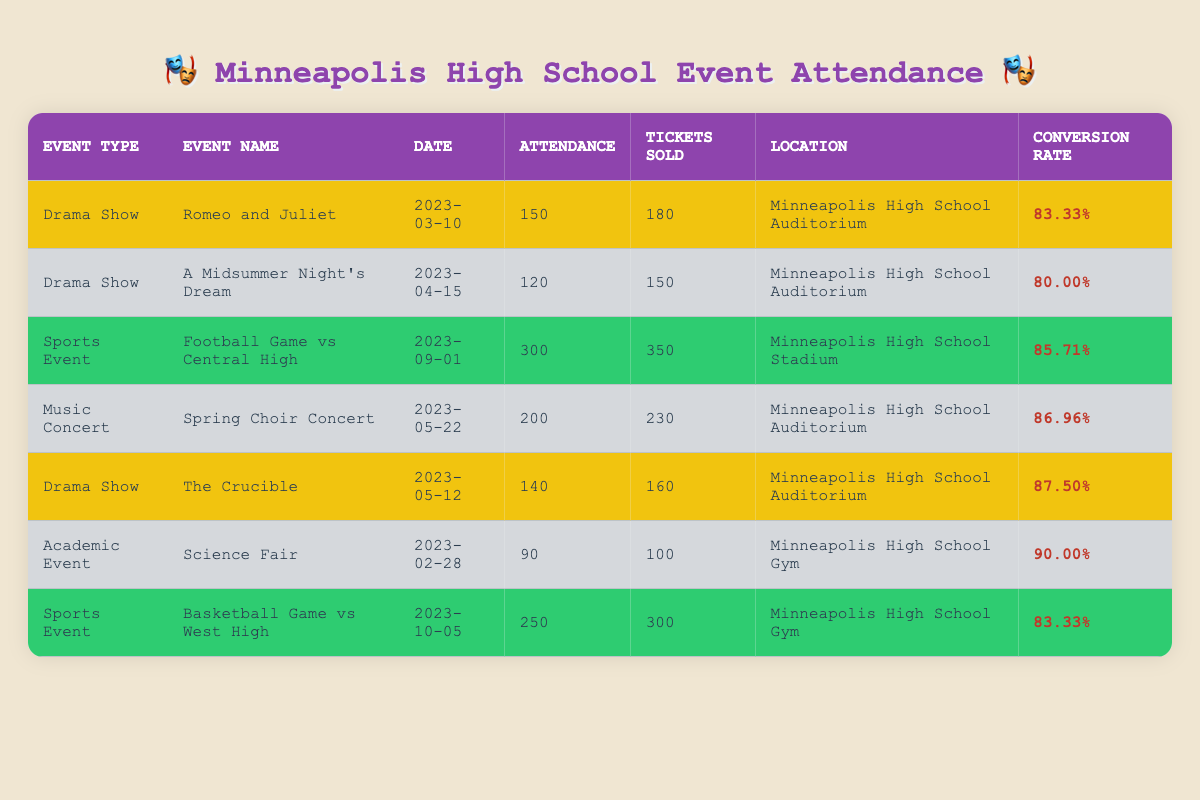What was the attendance of the "A Midsummer Night's Dream" drama show? The event name for "A Midsummer Night's Dream" is listed in the table under the Drama Show category, with the attendance recorded as 120.
Answer: 120 What is the conversion rate for the Spring Choir Concert? The Spring Choir Concert is listed in the table, and its conversion rate is shown as 86.96%.
Answer: 86.96% How many total tickets were sold for all drama shows combined? The drama shows listed are "Romeo and Juliet" (180), "A Midsummer Night's Dream" (150), and "The Crucible" (160). Adding these values gives 180 + 150 + 160 = 490 total tickets sold.
Answer: 490 Is the attendance for the "Science Fair" higher than that of "The Crucible"? The attendance for the Science Fair is 90, while The Crucible has an attendance of 140. Comparing these two values, 90 is less than 140, making the statement false.
Answer: No What is the average attendance for all drama shows? The attendance numbers for the drama shows are 150 (Romeo and Juliet), 120 (A Midsummer Night's Dream), and 140 (The Crucible). To find the average, we total these values: 150 + 120 + 140 = 410, and then divide by 3, resulting in an average of 410/3 = 136.67.
Answer: 136.67 What event had the highest attendance? Looking at the attendance values in the table, the event with the highest attendance is the Football Game vs Central High, with 300 attendees.
Answer: 300 What is the total attendance across all events? Summing the attendance for all listed events: 150 (Romeo and Juliet) + 120 (A Midsummer Night's Dream) + 300 (Football Game) + 200 (Spring Choir Concert) + 140 (The Crucible) + 90 (Science Fair) + 250 (Basketball Game) = 1,250 total attendees across all events.
Answer: 1250 Did the Football Game sell more tickets than any drama show? The Football Game had 350 tickets sold, while the maximum tickets sold for any drama show is 180 (Romeo and Juliet). Since 350 is greater than 180, the statement is true.
Answer: Yes Which event had the lowest conversion rate? By comparing the conversion rates: Romeo and Juliet (83.33%), A Midsummer Night's Dream (80.00%), The Crucible (87.50%), the Science Fair (90.00%), and both sports events (85.71% and 83.33%), A Midsummer Night's Dream has the lowest conversion rate of 80.00%.
Answer: 80.00 